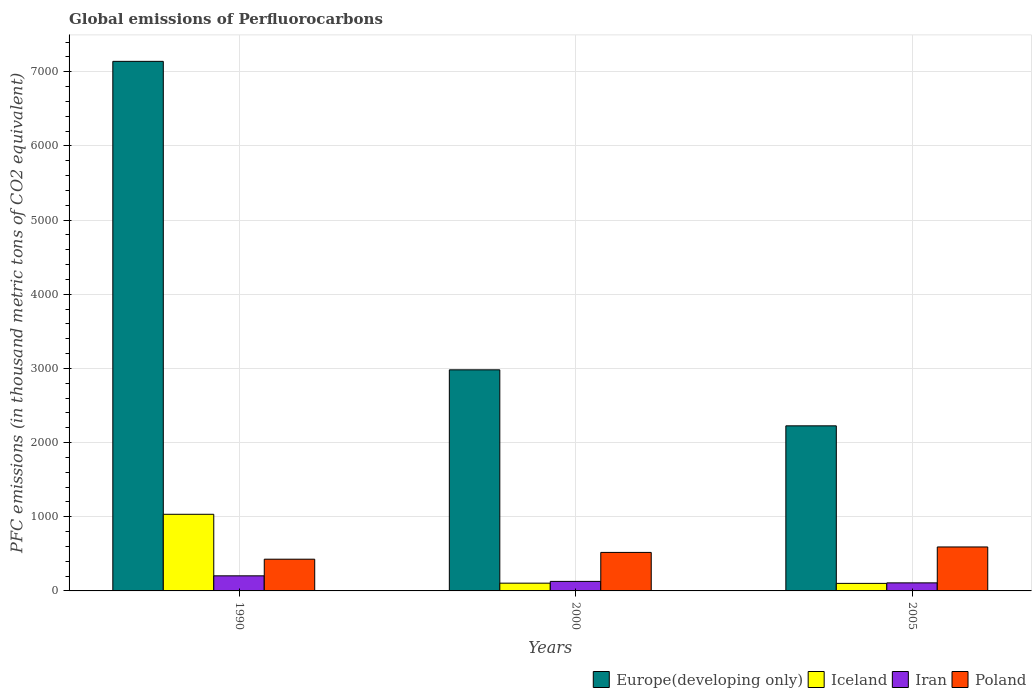Are the number of bars on each tick of the X-axis equal?
Ensure brevity in your answer.  Yes. How many bars are there on the 2nd tick from the right?
Your answer should be very brief. 4. What is the label of the 3rd group of bars from the left?
Your answer should be compact. 2005. In how many cases, is the number of bars for a given year not equal to the number of legend labels?
Provide a short and direct response. 0. What is the global emissions of Perfluorocarbons in Iran in 2005?
Offer a very short reply. 108.5. Across all years, what is the maximum global emissions of Perfluorocarbons in Poland?
Make the answer very short. 592.7. Across all years, what is the minimum global emissions of Perfluorocarbons in Iran?
Make the answer very short. 108.5. In which year was the global emissions of Perfluorocarbons in Iceland maximum?
Your response must be concise. 1990. In which year was the global emissions of Perfluorocarbons in Iceland minimum?
Your response must be concise. 2005. What is the total global emissions of Perfluorocarbons in Europe(developing only) in the graph?
Offer a terse response. 1.23e+04. What is the difference between the global emissions of Perfluorocarbons in Poland in 2000 and that in 2005?
Offer a terse response. -73.4. What is the difference between the global emissions of Perfluorocarbons in Poland in 2000 and the global emissions of Perfluorocarbons in Europe(developing only) in 1990?
Offer a very short reply. -6621.5. What is the average global emissions of Perfluorocarbons in Iceland per year?
Offer a very short reply. 413.2. In the year 1990, what is the difference between the global emissions of Perfluorocarbons in Iran and global emissions of Perfluorocarbons in Iceland?
Your answer should be very brief. -829.9. What is the ratio of the global emissions of Perfluorocarbons in Poland in 2000 to that in 2005?
Provide a short and direct response. 0.88. Is the difference between the global emissions of Perfluorocarbons in Iran in 1990 and 2005 greater than the difference between the global emissions of Perfluorocarbons in Iceland in 1990 and 2005?
Provide a succinct answer. No. What is the difference between the highest and the second highest global emissions of Perfluorocarbons in Iceland?
Offer a very short reply. 928.8. What is the difference between the highest and the lowest global emissions of Perfluorocarbons in Iran?
Give a very brief answer. 95. In how many years, is the global emissions of Perfluorocarbons in Europe(developing only) greater than the average global emissions of Perfluorocarbons in Europe(developing only) taken over all years?
Offer a terse response. 1. Is it the case that in every year, the sum of the global emissions of Perfluorocarbons in Iran and global emissions of Perfluorocarbons in Europe(developing only) is greater than the sum of global emissions of Perfluorocarbons in Iceland and global emissions of Perfluorocarbons in Poland?
Keep it short and to the point. Yes. What does the 2nd bar from the left in 1990 represents?
Offer a very short reply. Iceland. Is it the case that in every year, the sum of the global emissions of Perfluorocarbons in Iceland and global emissions of Perfluorocarbons in Iran is greater than the global emissions of Perfluorocarbons in Poland?
Your response must be concise. No. How many bars are there?
Give a very brief answer. 12. Are all the bars in the graph horizontal?
Provide a short and direct response. No. How many years are there in the graph?
Provide a succinct answer. 3. Does the graph contain grids?
Your answer should be compact. Yes. Where does the legend appear in the graph?
Your answer should be compact. Bottom right. What is the title of the graph?
Your response must be concise. Global emissions of Perfluorocarbons. Does "French Polynesia" appear as one of the legend labels in the graph?
Your response must be concise. No. What is the label or title of the Y-axis?
Offer a very short reply. PFC emissions (in thousand metric tons of CO2 equivalent). What is the PFC emissions (in thousand metric tons of CO2 equivalent) of Europe(developing only) in 1990?
Your answer should be very brief. 7140.8. What is the PFC emissions (in thousand metric tons of CO2 equivalent) in Iceland in 1990?
Keep it short and to the point. 1033.4. What is the PFC emissions (in thousand metric tons of CO2 equivalent) in Iran in 1990?
Ensure brevity in your answer.  203.5. What is the PFC emissions (in thousand metric tons of CO2 equivalent) of Poland in 1990?
Your response must be concise. 427.8. What is the PFC emissions (in thousand metric tons of CO2 equivalent) of Europe(developing only) in 2000?
Offer a very short reply. 2981.2. What is the PFC emissions (in thousand metric tons of CO2 equivalent) in Iceland in 2000?
Your answer should be compact. 104.6. What is the PFC emissions (in thousand metric tons of CO2 equivalent) in Iran in 2000?
Provide a short and direct response. 128.5. What is the PFC emissions (in thousand metric tons of CO2 equivalent) in Poland in 2000?
Give a very brief answer. 519.3. What is the PFC emissions (in thousand metric tons of CO2 equivalent) in Europe(developing only) in 2005?
Make the answer very short. 2226.02. What is the PFC emissions (in thousand metric tons of CO2 equivalent) of Iceland in 2005?
Give a very brief answer. 101.6. What is the PFC emissions (in thousand metric tons of CO2 equivalent) of Iran in 2005?
Your answer should be very brief. 108.5. What is the PFC emissions (in thousand metric tons of CO2 equivalent) in Poland in 2005?
Give a very brief answer. 592.7. Across all years, what is the maximum PFC emissions (in thousand metric tons of CO2 equivalent) of Europe(developing only)?
Your answer should be compact. 7140.8. Across all years, what is the maximum PFC emissions (in thousand metric tons of CO2 equivalent) in Iceland?
Your response must be concise. 1033.4. Across all years, what is the maximum PFC emissions (in thousand metric tons of CO2 equivalent) in Iran?
Your answer should be very brief. 203.5. Across all years, what is the maximum PFC emissions (in thousand metric tons of CO2 equivalent) in Poland?
Your response must be concise. 592.7. Across all years, what is the minimum PFC emissions (in thousand metric tons of CO2 equivalent) in Europe(developing only)?
Give a very brief answer. 2226.02. Across all years, what is the minimum PFC emissions (in thousand metric tons of CO2 equivalent) of Iceland?
Provide a succinct answer. 101.6. Across all years, what is the minimum PFC emissions (in thousand metric tons of CO2 equivalent) in Iran?
Your answer should be compact. 108.5. Across all years, what is the minimum PFC emissions (in thousand metric tons of CO2 equivalent) in Poland?
Your answer should be compact. 427.8. What is the total PFC emissions (in thousand metric tons of CO2 equivalent) in Europe(developing only) in the graph?
Your answer should be very brief. 1.23e+04. What is the total PFC emissions (in thousand metric tons of CO2 equivalent) in Iceland in the graph?
Provide a succinct answer. 1239.6. What is the total PFC emissions (in thousand metric tons of CO2 equivalent) in Iran in the graph?
Keep it short and to the point. 440.5. What is the total PFC emissions (in thousand metric tons of CO2 equivalent) in Poland in the graph?
Your answer should be very brief. 1539.8. What is the difference between the PFC emissions (in thousand metric tons of CO2 equivalent) of Europe(developing only) in 1990 and that in 2000?
Ensure brevity in your answer.  4159.6. What is the difference between the PFC emissions (in thousand metric tons of CO2 equivalent) of Iceland in 1990 and that in 2000?
Keep it short and to the point. 928.8. What is the difference between the PFC emissions (in thousand metric tons of CO2 equivalent) in Iran in 1990 and that in 2000?
Provide a short and direct response. 75. What is the difference between the PFC emissions (in thousand metric tons of CO2 equivalent) of Poland in 1990 and that in 2000?
Give a very brief answer. -91.5. What is the difference between the PFC emissions (in thousand metric tons of CO2 equivalent) of Europe(developing only) in 1990 and that in 2005?
Ensure brevity in your answer.  4914.78. What is the difference between the PFC emissions (in thousand metric tons of CO2 equivalent) of Iceland in 1990 and that in 2005?
Give a very brief answer. 931.8. What is the difference between the PFC emissions (in thousand metric tons of CO2 equivalent) of Iran in 1990 and that in 2005?
Give a very brief answer. 95. What is the difference between the PFC emissions (in thousand metric tons of CO2 equivalent) of Poland in 1990 and that in 2005?
Your answer should be very brief. -164.9. What is the difference between the PFC emissions (in thousand metric tons of CO2 equivalent) in Europe(developing only) in 2000 and that in 2005?
Offer a terse response. 755.18. What is the difference between the PFC emissions (in thousand metric tons of CO2 equivalent) in Iceland in 2000 and that in 2005?
Give a very brief answer. 3. What is the difference between the PFC emissions (in thousand metric tons of CO2 equivalent) in Poland in 2000 and that in 2005?
Offer a terse response. -73.4. What is the difference between the PFC emissions (in thousand metric tons of CO2 equivalent) in Europe(developing only) in 1990 and the PFC emissions (in thousand metric tons of CO2 equivalent) in Iceland in 2000?
Ensure brevity in your answer.  7036.2. What is the difference between the PFC emissions (in thousand metric tons of CO2 equivalent) of Europe(developing only) in 1990 and the PFC emissions (in thousand metric tons of CO2 equivalent) of Iran in 2000?
Your answer should be compact. 7012.3. What is the difference between the PFC emissions (in thousand metric tons of CO2 equivalent) in Europe(developing only) in 1990 and the PFC emissions (in thousand metric tons of CO2 equivalent) in Poland in 2000?
Offer a terse response. 6621.5. What is the difference between the PFC emissions (in thousand metric tons of CO2 equivalent) in Iceland in 1990 and the PFC emissions (in thousand metric tons of CO2 equivalent) in Iran in 2000?
Ensure brevity in your answer.  904.9. What is the difference between the PFC emissions (in thousand metric tons of CO2 equivalent) of Iceland in 1990 and the PFC emissions (in thousand metric tons of CO2 equivalent) of Poland in 2000?
Offer a terse response. 514.1. What is the difference between the PFC emissions (in thousand metric tons of CO2 equivalent) of Iran in 1990 and the PFC emissions (in thousand metric tons of CO2 equivalent) of Poland in 2000?
Your response must be concise. -315.8. What is the difference between the PFC emissions (in thousand metric tons of CO2 equivalent) in Europe(developing only) in 1990 and the PFC emissions (in thousand metric tons of CO2 equivalent) in Iceland in 2005?
Your answer should be very brief. 7039.2. What is the difference between the PFC emissions (in thousand metric tons of CO2 equivalent) of Europe(developing only) in 1990 and the PFC emissions (in thousand metric tons of CO2 equivalent) of Iran in 2005?
Ensure brevity in your answer.  7032.3. What is the difference between the PFC emissions (in thousand metric tons of CO2 equivalent) in Europe(developing only) in 1990 and the PFC emissions (in thousand metric tons of CO2 equivalent) in Poland in 2005?
Make the answer very short. 6548.1. What is the difference between the PFC emissions (in thousand metric tons of CO2 equivalent) in Iceland in 1990 and the PFC emissions (in thousand metric tons of CO2 equivalent) in Iran in 2005?
Your answer should be very brief. 924.9. What is the difference between the PFC emissions (in thousand metric tons of CO2 equivalent) of Iceland in 1990 and the PFC emissions (in thousand metric tons of CO2 equivalent) of Poland in 2005?
Offer a very short reply. 440.7. What is the difference between the PFC emissions (in thousand metric tons of CO2 equivalent) in Iran in 1990 and the PFC emissions (in thousand metric tons of CO2 equivalent) in Poland in 2005?
Provide a short and direct response. -389.2. What is the difference between the PFC emissions (in thousand metric tons of CO2 equivalent) of Europe(developing only) in 2000 and the PFC emissions (in thousand metric tons of CO2 equivalent) of Iceland in 2005?
Provide a succinct answer. 2879.6. What is the difference between the PFC emissions (in thousand metric tons of CO2 equivalent) of Europe(developing only) in 2000 and the PFC emissions (in thousand metric tons of CO2 equivalent) of Iran in 2005?
Provide a succinct answer. 2872.7. What is the difference between the PFC emissions (in thousand metric tons of CO2 equivalent) in Europe(developing only) in 2000 and the PFC emissions (in thousand metric tons of CO2 equivalent) in Poland in 2005?
Give a very brief answer. 2388.5. What is the difference between the PFC emissions (in thousand metric tons of CO2 equivalent) of Iceland in 2000 and the PFC emissions (in thousand metric tons of CO2 equivalent) of Iran in 2005?
Give a very brief answer. -3.9. What is the difference between the PFC emissions (in thousand metric tons of CO2 equivalent) in Iceland in 2000 and the PFC emissions (in thousand metric tons of CO2 equivalent) in Poland in 2005?
Your response must be concise. -488.1. What is the difference between the PFC emissions (in thousand metric tons of CO2 equivalent) in Iran in 2000 and the PFC emissions (in thousand metric tons of CO2 equivalent) in Poland in 2005?
Offer a terse response. -464.2. What is the average PFC emissions (in thousand metric tons of CO2 equivalent) in Europe(developing only) per year?
Provide a succinct answer. 4116.01. What is the average PFC emissions (in thousand metric tons of CO2 equivalent) of Iceland per year?
Provide a short and direct response. 413.2. What is the average PFC emissions (in thousand metric tons of CO2 equivalent) in Iran per year?
Offer a very short reply. 146.83. What is the average PFC emissions (in thousand metric tons of CO2 equivalent) in Poland per year?
Offer a very short reply. 513.27. In the year 1990, what is the difference between the PFC emissions (in thousand metric tons of CO2 equivalent) of Europe(developing only) and PFC emissions (in thousand metric tons of CO2 equivalent) of Iceland?
Ensure brevity in your answer.  6107.4. In the year 1990, what is the difference between the PFC emissions (in thousand metric tons of CO2 equivalent) of Europe(developing only) and PFC emissions (in thousand metric tons of CO2 equivalent) of Iran?
Ensure brevity in your answer.  6937.3. In the year 1990, what is the difference between the PFC emissions (in thousand metric tons of CO2 equivalent) of Europe(developing only) and PFC emissions (in thousand metric tons of CO2 equivalent) of Poland?
Offer a terse response. 6713. In the year 1990, what is the difference between the PFC emissions (in thousand metric tons of CO2 equivalent) in Iceland and PFC emissions (in thousand metric tons of CO2 equivalent) in Iran?
Your answer should be very brief. 829.9. In the year 1990, what is the difference between the PFC emissions (in thousand metric tons of CO2 equivalent) in Iceland and PFC emissions (in thousand metric tons of CO2 equivalent) in Poland?
Make the answer very short. 605.6. In the year 1990, what is the difference between the PFC emissions (in thousand metric tons of CO2 equivalent) in Iran and PFC emissions (in thousand metric tons of CO2 equivalent) in Poland?
Ensure brevity in your answer.  -224.3. In the year 2000, what is the difference between the PFC emissions (in thousand metric tons of CO2 equivalent) of Europe(developing only) and PFC emissions (in thousand metric tons of CO2 equivalent) of Iceland?
Keep it short and to the point. 2876.6. In the year 2000, what is the difference between the PFC emissions (in thousand metric tons of CO2 equivalent) in Europe(developing only) and PFC emissions (in thousand metric tons of CO2 equivalent) in Iran?
Offer a terse response. 2852.7. In the year 2000, what is the difference between the PFC emissions (in thousand metric tons of CO2 equivalent) of Europe(developing only) and PFC emissions (in thousand metric tons of CO2 equivalent) of Poland?
Offer a very short reply. 2461.9. In the year 2000, what is the difference between the PFC emissions (in thousand metric tons of CO2 equivalent) in Iceland and PFC emissions (in thousand metric tons of CO2 equivalent) in Iran?
Offer a terse response. -23.9. In the year 2000, what is the difference between the PFC emissions (in thousand metric tons of CO2 equivalent) in Iceland and PFC emissions (in thousand metric tons of CO2 equivalent) in Poland?
Offer a very short reply. -414.7. In the year 2000, what is the difference between the PFC emissions (in thousand metric tons of CO2 equivalent) in Iran and PFC emissions (in thousand metric tons of CO2 equivalent) in Poland?
Provide a short and direct response. -390.8. In the year 2005, what is the difference between the PFC emissions (in thousand metric tons of CO2 equivalent) in Europe(developing only) and PFC emissions (in thousand metric tons of CO2 equivalent) in Iceland?
Offer a very short reply. 2124.42. In the year 2005, what is the difference between the PFC emissions (in thousand metric tons of CO2 equivalent) in Europe(developing only) and PFC emissions (in thousand metric tons of CO2 equivalent) in Iran?
Offer a terse response. 2117.52. In the year 2005, what is the difference between the PFC emissions (in thousand metric tons of CO2 equivalent) in Europe(developing only) and PFC emissions (in thousand metric tons of CO2 equivalent) in Poland?
Ensure brevity in your answer.  1633.32. In the year 2005, what is the difference between the PFC emissions (in thousand metric tons of CO2 equivalent) of Iceland and PFC emissions (in thousand metric tons of CO2 equivalent) of Iran?
Your answer should be very brief. -6.9. In the year 2005, what is the difference between the PFC emissions (in thousand metric tons of CO2 equivalent) of Iceland and PFC emissions (in thousand metric tons of CO2 equivalent) of Poland?
Provide a succinct answer. -491.1. In the year 2005, what is the difference between the PFC emissions (in thousand metric tons of CO2 equivalent) of Iran and PFC emissions (in thousand metric tons of CO2 equivalent) of Poland?
Your answer should be compact. -484.2. What is the ratio of the PFC emissions (in thousand metric tons of CO2 equivalent) in Europe(developing only) in 1990 to that in 2000?
Give a very brief answer. 2.4. What is the ratio of the PFC emissions (in thousand metric tons of CO2 equivalent) in Iceland in 1990 to that in 2000?
Provide a succinct answer. 9.88. What is the ratio of the PFC emissions (in thousand metric tons of CO2 equivalent) of Iran in 1990 to that in 2000?
Make the answer very short. 1.58. What is the ratio of the PFC emissions (in thousand metric tons of CO2 equivalent) in Poland in 1990 to that in 2000?
Ensure brevity in your answer.  0.82. What is the ratio of the PFC emissions (in thousand metric tons of CO2 equivalent) of Europe(developing only) in 1990 to that in 2005?
Your answer should be compact. 3.21. What is the ratio of the PFC emissions (in thousand metric tons of CO2 equivalent) in Iceland in 1990 to that in 2005?
Provide a succinct answer. 10.17. What is the ratio of the PFC emissions (in thousand metric tons of CO2 equivalent) in Iran in 1990 to that in 2005?
Your response must be concise. 1.88. What is the ratio of the PFC emissions (in thousand metric tons of CO2 equivalent) in Poland in 1990 to that in 2005?
Your answer should be very brief. 0.72. What is the ratio of the PFC emissions (in thousand metric tons of CO2 equivalent) of Europe(developing only) in 2000 to that in 2005?
Your answer should be compact. 1.34. What is the ratio of the PFC emissions (in thousand metric tons of CO2 equivalent) in Iceland in 2000 to that in 2005?
Make the answer very short. 1.03. What is the ratio of the PFC emissions (in thousand metric tons of CO2 equivalent) of Iran in 2000 to that in 2005?
Your response must be concise. 1.18. What is the ratio of the PFC emissions (in thousand metric tons of CO2 equivalent) in Poland in 2000 to that in 2005?
Ensure brevity in your answer.  0.88. What is the difference between the highest and the second highest PFC emissions (in thousand metric tons of CO2 equivalent) of Europe(developing only)?
Offer a terse response. 4159.6. What is the difference between the highest and the second highest PFC emissions (in thousand metric tons of CO2 equivalent) of Iceland?
Your answer should be very brief. 928.8. What is the difference between the highest and the second highest PFC emissions (in thousand metric tons of CO2 equivalent) in Iran?
Offer a terse response. 75. What is the difference between the highest and the second highest PFC emissions (in thousand metric tons of CO2 equivalent) of Poland?
Give a very brief answer. 73.4. What is the difference between the highest and the lowest PFC emissions (in thousand metric tons of CO2 equivalent) in Europe(developing only)?
Ensure brevity in your answer.  4914.78. What is the difference between the highest and the lowest PFC emissions (in thousand metric tons of CO2 equivalent) in Iceland?
Make the answer very short. 931.8. What is the difference between the highest and the lowest PFC emissions (in thousand metric tons of CO2 equivalent) of Iran?
Provide a succinct answer. 95. What is the difference between the highest and the lowest PFC emissions (in thousand metric tons of CO2 equivalent) of Poland?
Your answer should be very brief. 164.9. 